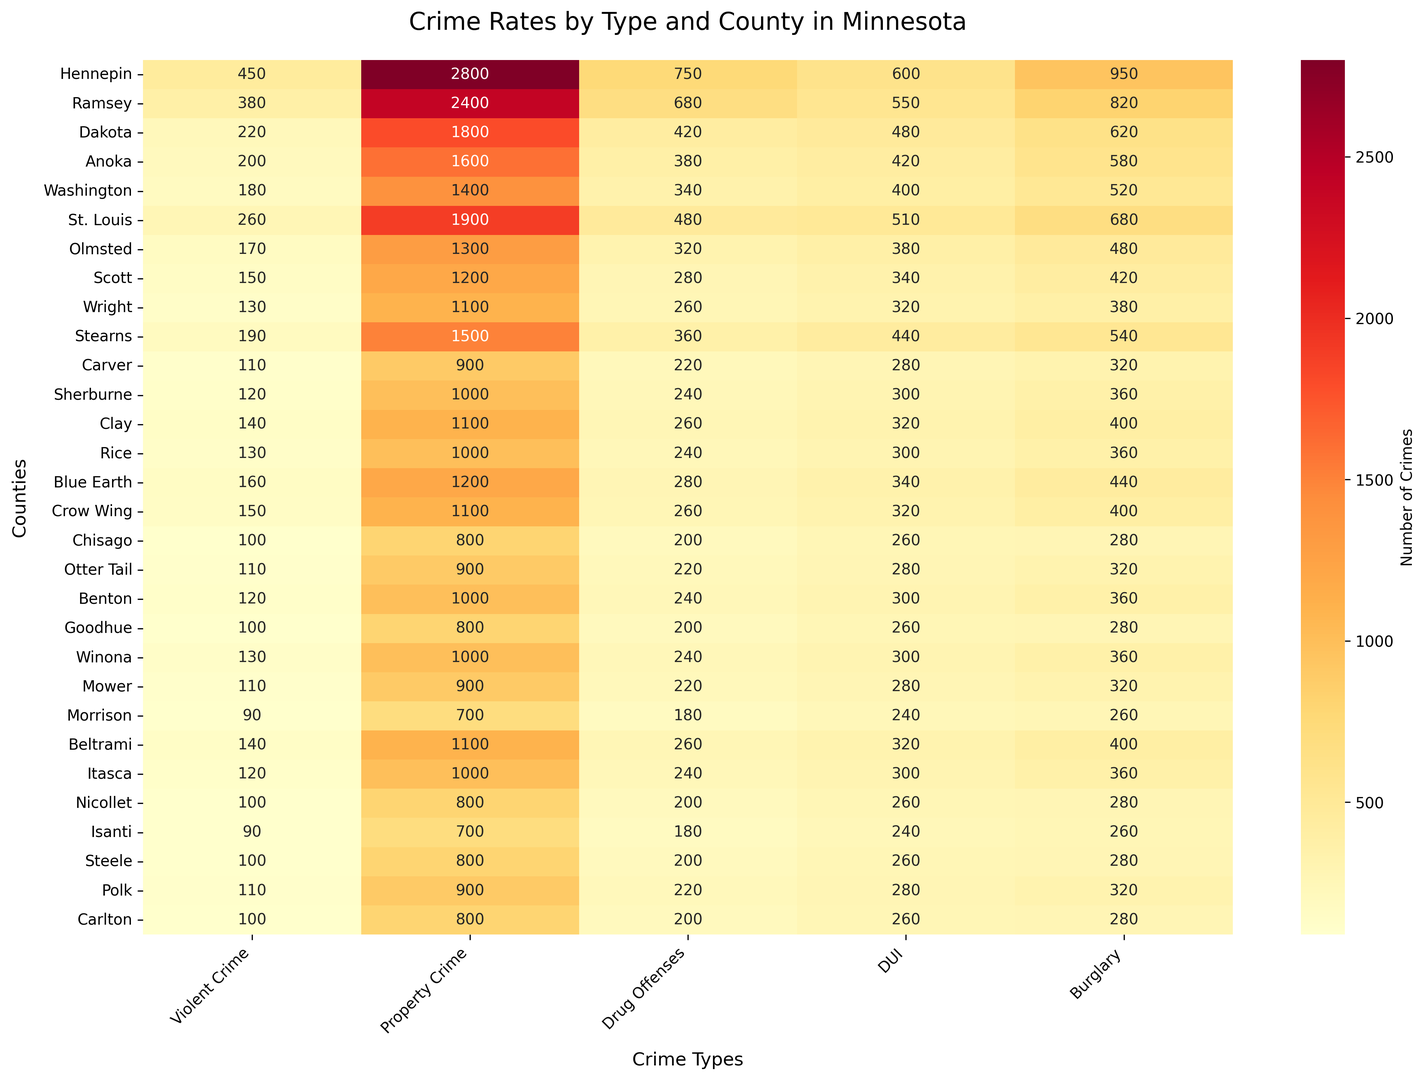What is the total number of property crimes in Hennepin and Ramsey counties combined? First, find the number of property crimes in Hennepin and Ramsey counties from the heatmap (2800 and 2400 respectively). Then, sum these to get the total: 2800 + 2400 = 5200.
Answer: 5200 Which county has the lowest number of DUI offenses? Look at the DUI column in the heatmap to identify the lowest value. Morrison County has the lowest number of DUI offenses at 240.
Answer: Morrison Does Dakota County have more drug offenses or burglaries? Compare the number in the Drug Offenses and Burglary columns for Dakota County. Drug offenses are 420 and burglaries are 620. Since 620 is greater than 420, Dakota has more burglaries.
Answer: Burglaries Which type of crime is most frequent in St. Louis County? Examine the row for St. Louis County and identify the highest value among the crime types. Property crime is the most frequent with 1900 incidents.
Answer: Property Crime How does the number of violent crimes in Anoka County compare to those in Stearns County? Look at the Violent Crime column for both Anoka (200) and Stearns (190). Anoka County has 200 violent crimes, which is greater than Stearns County's 190.
Answer: Anoka has more Which county has the highest number of property crimes, and what is that number? Find the highest value in the Property Crime column. Hennepin County has the highest number of property crimes with 2800.
Answer: Hennepin, 2800 How many total burglaries are there in Winona, Crow Wing, and Chisago counties combined? Add the number of burglaries in those counties: Winona (360), Crow Wing (400), and Chisago (280). The total is 360 + 400 + 280 = 1040.
Answer: 1040 What is the average number of violent crimes across all counties shown in the heatmap? Sum all values in the Violent Crime column and divide by the number of counties. Total violent crimes = 4530. Number of counties = 30. Average = 4530 / 30 = 151.
Answer: 151 Which county has the darkest color in the Burglary column, and what does it represent? Identify the darkest color in the Burglary column, which indicates the highest value. Hennepin County has the darkest color with 950 burglaries.
Answer: Hennepin, 950 Is the number of DUI offenses in Ramsey County greater than the number of drug offenses in Olmsted County? Compare the number of DUI offenses in Ramsey (550) to the number of drug offenses in Olmsted (320). 550 is greater than 320.
Answer: Yes 